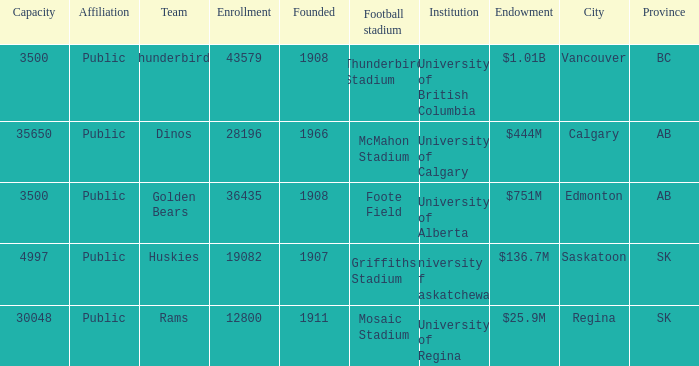What year was mcmahon stadium founded? 1966.0. 